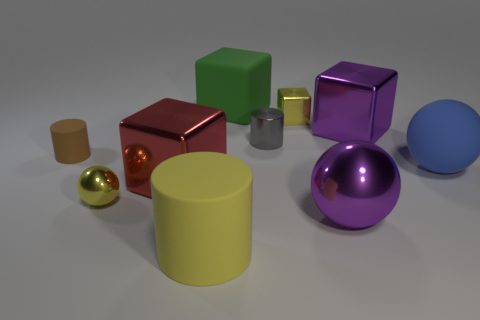What is the size of the yellow sphere?
Your answer should be compact. Small. How many blue objects are big rubber cubes or big rubber spheres?
Give a very brief answer. 1. There is a rubber object that is on the right side of the small yellow metallic thing that is behind the blue matte thing; what is its size?
Ensure brevity in your answer.  Large. Does the tiny sphere have the same color as the large sphere in front of the rubber sphere?
Offer a terse response. No. What number of other things are there of the same material as the gray cylinder
Your response must be concise. 5. The blue object that is made of the same material as the green thing is what shape?
Provide a succinct answer. Sphere. Are there any other things of the same color as the tiny metallic sphere?
Your answer should be very brief. Yes. The matte cylinder that is the same color as the small metallic ball is what size?
Give a very brief answer. Large. Is the number of large spheres that are behind the big matte cube greater than the number of green rubber objects?
Give a very brief answer. No. Do the red thing and the purple metal object that is on the right side of the large purple ball have the same shape?
Make the answer very short. Yes. 